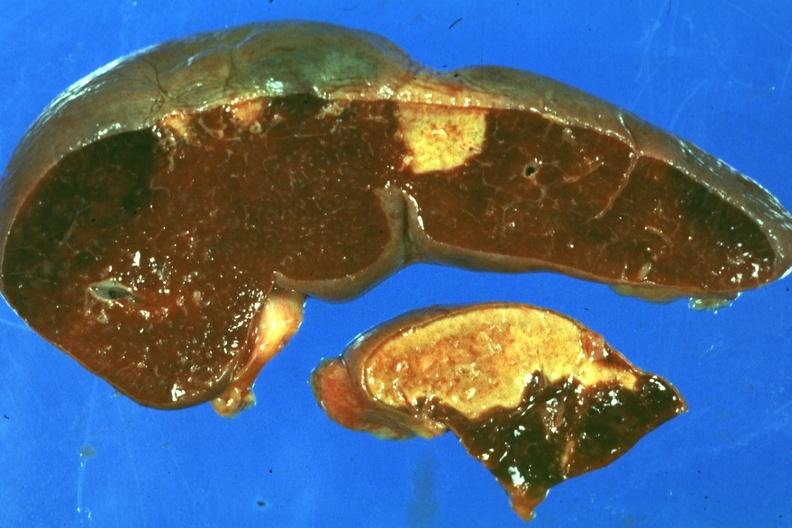does this image show typical lesion about a week or more of age?
Answer the question using a single word or phrase. Yes 